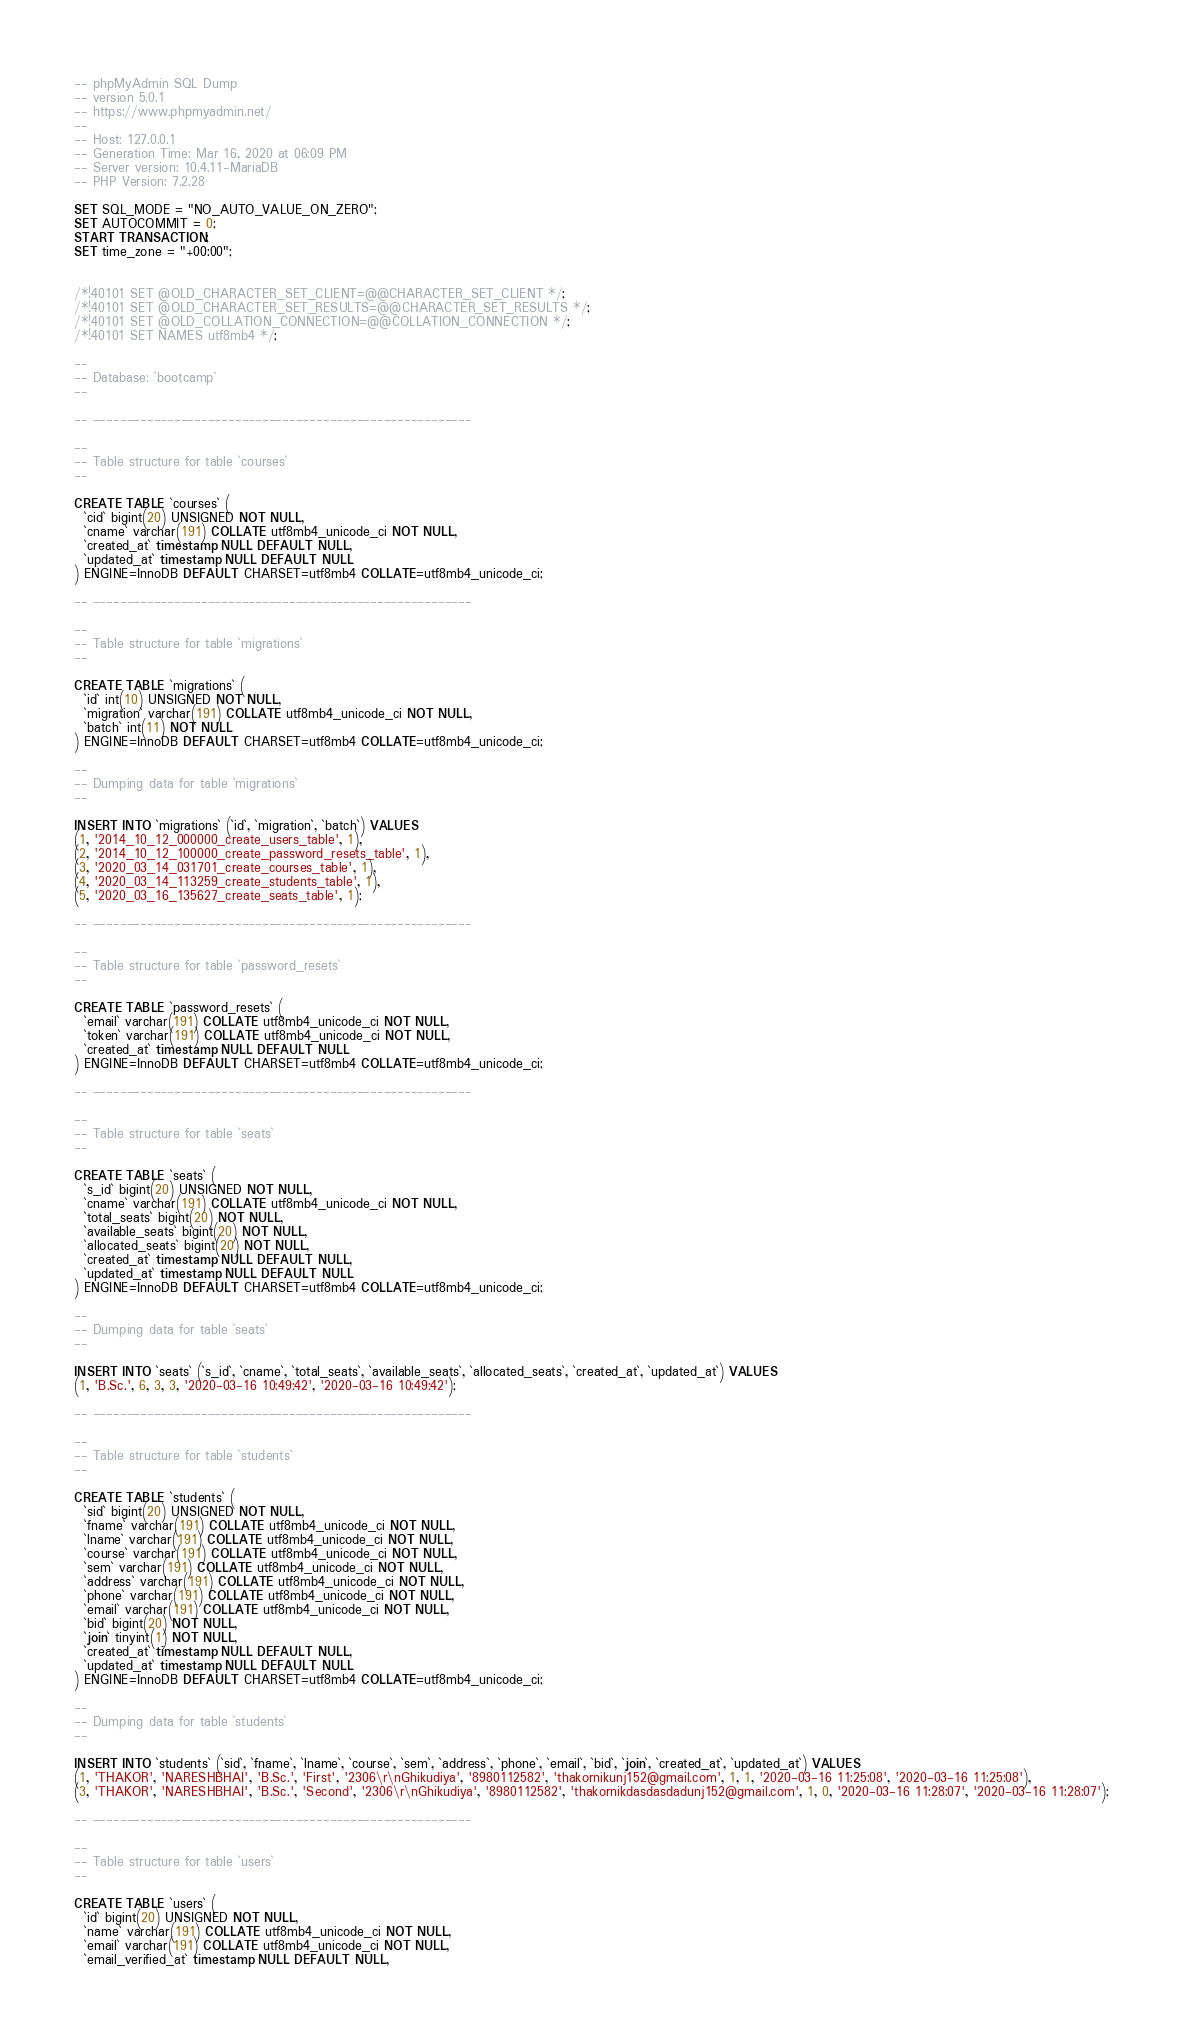<code> <loc_0><loc_0><loc_500><loc_500><_SQL_>-- phpMyAdmin SQL Dump
-- version 5.0.1
-- https://www.phpmyadmin.net/
--
-- Host: 127.0.0.1
-- Generation Time: Mar 16, 2020 at 06:09 PM
-- Server version: 10.4.11-MariaDB
-- PHP Version: 7.2.28

SET SQL_MODE = "NO_AUTO_VALUE_ON_ZERO";
SET AUTOCOMMIT = 0;
START TRANSACTION;
SET time_zone = "+00:00";


/*!40101 SET @OLD_CHARACTER_SET_CLIENT=@@CHARACTER_SET_CLIENT */;
/*!40101 SET @OLD_CHARACTER_SET_RESULTS=@@CHARACTER_SET_RESULTS */;
/*!40101 SET @OLD_COLLATION_CONNECTION=@@COLLATION_CONNECTION */;
/*!40101 SET NAMES utf8mb4 */;

--
-- Database: `bootcamp`
--

-- --------------------------------------------------------

--
-- Table structure for table `courses`
--

CREATE TABLE `courses` (
  `cid` bigint(20) UNSIGNED NOT NULL,
  `cname` varchar(191) COLLATE utf8mb4_unicode_ci NOT NULL,
  `created_at` timestamp NULL DEFAULT NULL,
  `updated_at` timestamp NULL DEFAULT NULL
) ENGINE=InnoDB DEFAULT CHARSET=utf8mb4 COLLATE=utf8mb4_unicode_ci;

-- --------------------------------------------------------

--
-- Table structure for table `migrations`
--

CREATE TABLE `migrations` (
  `id` int(10) UNSIGNED NOT NULL,
  `migration` varchar(191) COLLATE utf8mb4_unicode_ci NOT NULL,
  `batch` int(11) NOT NULL
) ENGINE=InnoDB DEFAULT CHARSET=utf8mb4 COLLATE=utf8mb4_unicode_ci;

--
-- Dumping data for table `migrations`
--

INSERT INTO `migrations` (`id`, `migration`, `batch`) VALUES
(1, '2014_10_12_000000_create_users_table', 1),
(2, '2014_10_12_100000_create_password_resets_table', 1),
(3, '2020_03_14_031701_create_courses_table', 1),
(4, '2020_03_14_113259_create_students_table', 1),
(5, '2020_03_16_135627_create_seats_table', 1);

-- --------------------------------------------------------

--
-- Table structure for table `password_resets`
--

CREATE TABLE `password_resets` (
  `email` varchar(191) COLLATE utf8mb4_unicode_ci NOT NULL,
  `token` varchar(191) COLLATE utf8mb4_unicode_ci NOT NULL,
  `created_at` timestamp NULL DEFAULT NULL
) ENGINE=InnoDB DEFAULT CHARSET=utf8mb4 COLLATE=utf8mb4_unicode_ci;

-- --------------------------------------------------------

--
-- Table structure for table `seats`
--

CREATE TABLE `seats` (
  `s_id` bigint(20) UNSIGNED NOT NULL,
  `cname` varchar(191) COLLATE utf8mb4_unicode_ci NOT NULL,
  `total_seats` bigint(20) NOT NULL,
  `available_seats` bigint(20) NOT NULL,
  `allocated_seats` bigint(20) NOT NULL,
  `created_at` timestamp NULL DEFAULT NULL,
  `updated_at` timestamp NULL DEFAULT NULL
) ENGINE=InnoDB DEFAULT CHARSET=utf8mb4 COLLATE=utf8mb4_unicode_ci;

--
-- Dumping data for table `seats`
--

INSERT INTO `seats` (`s_id`, `cname`, `total_seats`, `available_seats`, `allocated_seats`, `created_at`, `updated_at`) VALUES
(1, 'B.Sc.', 6, 3, 3, '2020-03-16 10:49:42', '2020-03-16 10:49:42');

-- --------------------------------------------------------

--
-- Table structure for table `students`
--

CREATE TABLE `students` (
  `sid` bigint(20) UNSIGNED NOT NULL,
  `fname` varchar(191) COLLATE utf8mb4_unicode_ci NOT NULL,
  `lname` varchar(191) COLLATE utf8mb4_unicode_ci NOT NULL,
  `course` varchar(191) COLLATE utf8mb4_unicode_ci NOT NULL,
  `sem` varchar(191) COLLATE utf8mb4_unicode_ci NOT NULL,
  `address` varchar(191) COLLATE utf8mb4_unicode_ci NOT NULL,
  `phone` varchar(191) COLLATE utf8mb4_unicode_ci NOT NULL,
  `email` varchar(191) COLLATE utf8mb4_unicode_ci NOT NULL,
  `bid` bigint(20) NOT NULL,
  `join` tinyint(1) NOT NULL,
  `created_at` timestamp NULL DEFAULT NULL,
  `updated_at` timestamp NULL DEFAULT NULL
) ENGINE=InnoDB DEFAULT CHARSET=utf8mb4 COLLATE=utf8mb4_unicode_ci;

--
-- Dumping data for table `students`
--

INSERT INTO `students` (`sid`, `fname`, `lname`, `course`, `sem`, `address`, `phone`, `email`, `bid`, `join`, `created_at`, `updated_at`) VALUES
(1, 'THAKOR', 'NARESHBHAI', 'B.Sc.', 'First', '2306\r\nGhikudiya', '8980112582', 'thakornikunj152@gmail.com', 1, 1, '2020-03-16 11:25:08', '2020-03-16 11:25:08'),
(3, 'THAKOR', 'NARESHBHAI', 'B.Sc.', 'Second', '2306\r\nGhikudiya', '8980112582', 'thakornikdasdasdadunj152@gmail.com', 1, 0, '2020-03-16 11:28:07', '2020-03-16 11:28:07');

-- --------------------------------------------------------

--
-- Table structure for table `users`
--

CREATE TABLE `users` (
  `id` bigint(20) UNSIGNED NOT NULL,
  `name` varchar(191) COLLATE utf8mb4_unicode_ci NOT NULL,
  `email` varchar(191) COLLATE utf8mb4_unicode_ci NOT NULL,
  `email_verified_at` timestamp NULL DEFAULT NULL,</code> 